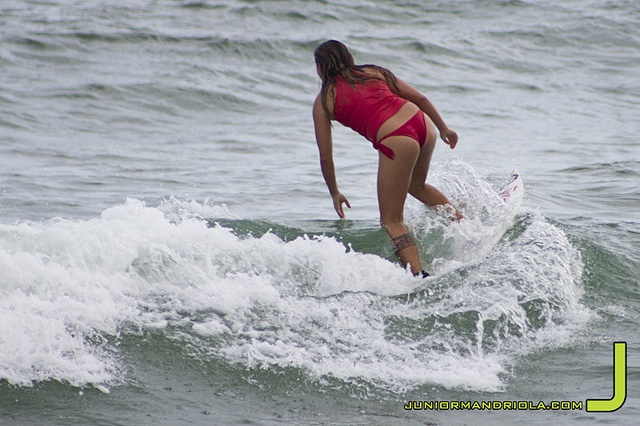Describe the objects in this image and their specific colors. I can see people in darkgray, maroon, brown, and black tones and surfboard in darkgray and lightgray tones in this image. 